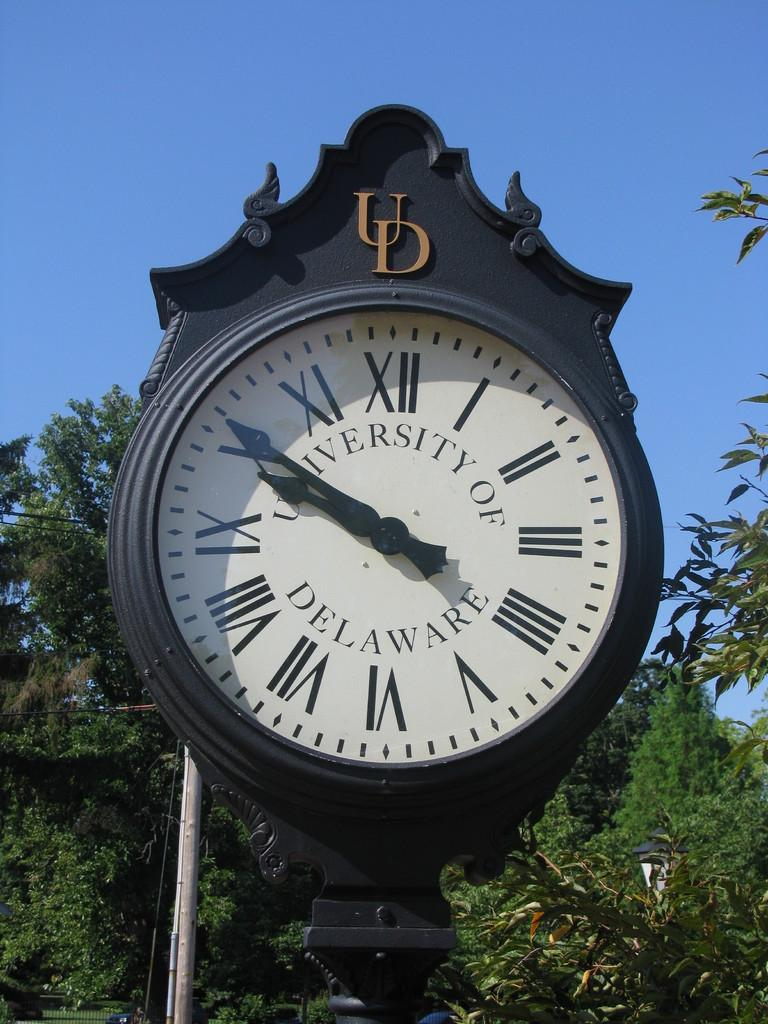<image>
Relay a brief, clear account of the picture shown. White and black clock which says University of Delaware in the middle. 